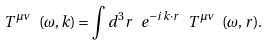<formula> <loc_0><loc_0><loc_500><loc_500>T ^ { \mu \nu } \ ( \omega , { k } ) = \int d ^ { 3 } r \ e ^ { - i { k } \cdot { r } } \ T ^ { \mu \nu } \ ( \omega , { r } ) .</formula> 